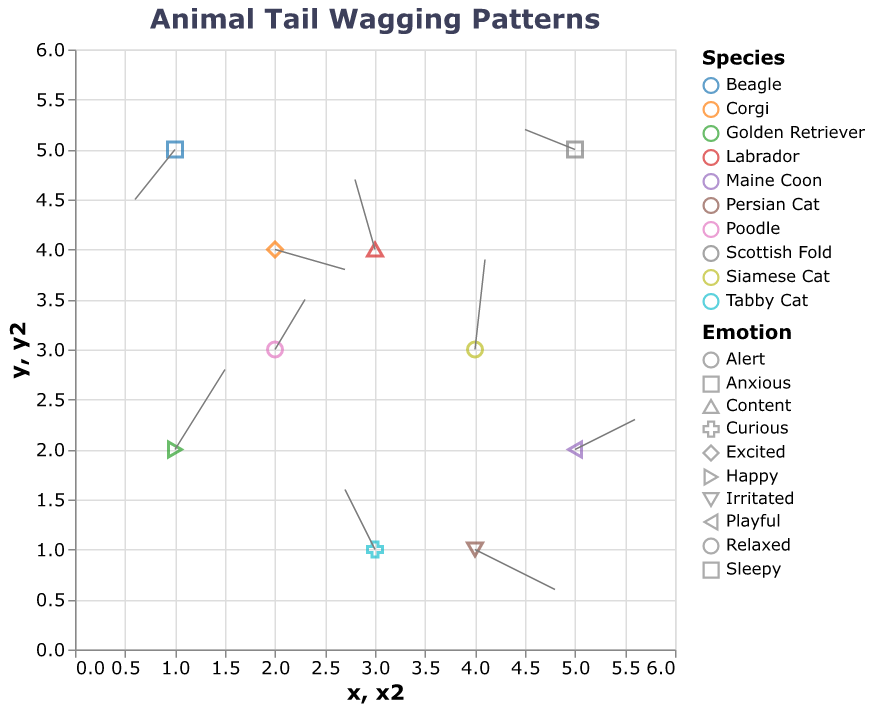How many different species of animals are represented in the plot? The color legend indicates different animal species. Counting the distinct colors gives the total number of species.
Answer: 10 What is the title of the plot? The title is positioned at the top of the plot.
Answer: Animal Tail Wagging Patterns How many animals are in an anxious state? The plot legend includes emotions, with one animal in an anxious state represented by a unique shape or tooltip.
Answer: 1 Which species shows the largest magnitude of tail wagging (u and v components combined)? To find this, calculate the magnitude of each vector (sqrt(u^2 + v^2)) and identify the maximum. Poodle: sqrt(0.3^2 + 0.5^2) ≈ 0.583. Golden Retriever: sqrt(0.5^2 + 0.8^2) ≈ 0.943. Retrieving these values for each species reveals the maximum.
Answer: Golden Retriever Which animal's emotion aligns with upward tail movement? Upward movement happens when v > 0. By examining the v components, we find that Golden Retriever, Poodle, Siamese Cat, Tabby Cat, Labrador, and Maine Coon exhibit upward tail movement.
Answer: Several animals: Golden Retriever, Poodle, Siamese Cat, Tabby Cat, Labrador, and Maine Coon What is the median x-coordinate of all data points? The x-coordinates are: 1, 2, 3, 4, 5, 1, 5, 3, 4,2. Sorting these values: 1, 1, 2, 2, 3, 3, 4, 4, 5, 5. The median value is the middle value of this sorted list.
Answer: 3 Which species has the smallest y-component (v) for its tail wagging? Examining the y-components for all species, we observe that Beagle has the smallest y-component v = -0.5.
Answer: Beagle Which animal is located furthest to the right? The x-coordinates in the plot show the horizontal position, with the highest value indicating the furthest right.
Answer: Maine Coon and Scottish Fold (both at x=5) Among the cats, which one shows the most horizontal tail movement? From the species labeled as cats, comparing the u values shows that Persian Cat has the largest magnitude of horizontal movement u=0.8.
Answer: Persian Cat What's the count of data points with both x and y coordinates greater than 3? Checking the coordinates where both x and y are greater than 3 reveals two such points: 4,3 Siamese Cat; 5,5 Scottish Fold.
Answer: 2 